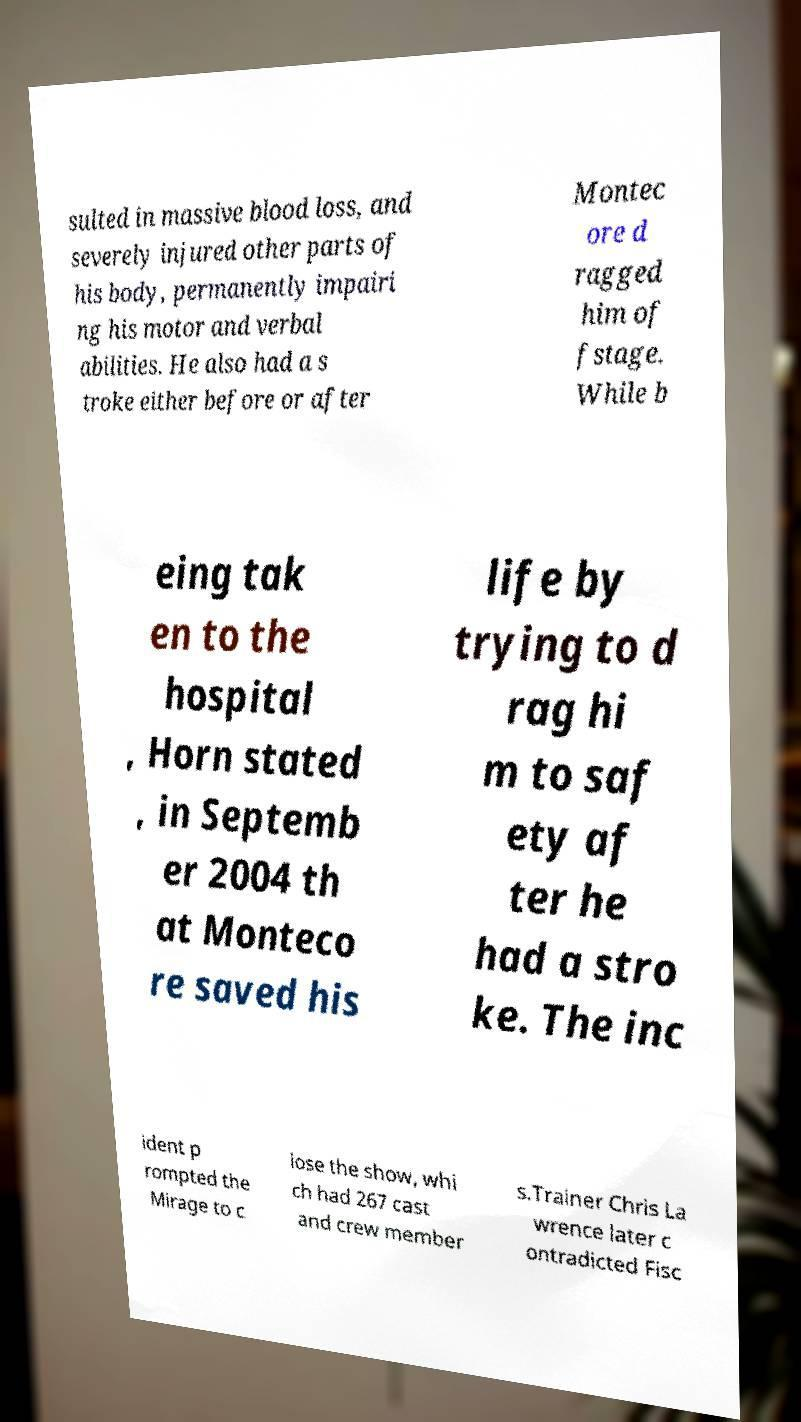What messages or text are displayed in this image? I need them in a readable, typed format. sulted in massive blood loss, and severely injured other parts of his body, permanently impairi ng his motor and verbal abilities. He also had a s troke either before or after Montec ore d ragged him of fstage. While b eing tak en to the hospital , Horn stated , in Septemb er 2004 th at Monteco re saved his life by trying to d rag hi m to saf ety af ter he had a stro ke. The inc ident p rompted the Mirage to c lose the show, whi ch had 267 cast and crew member s.Trainer Chris La wrence later c ontradicted Fisc 